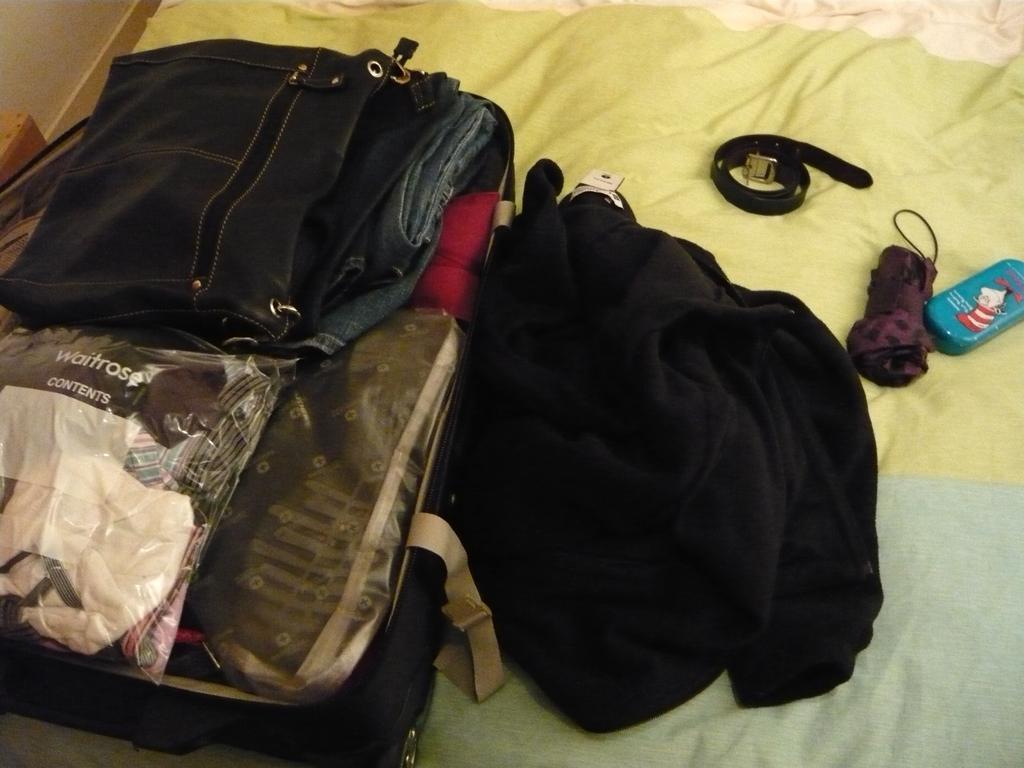Describe this image in one or two sentences. In this picture we have a bird which is covered with a cloth on the bed we can see every skate cloth and a box and an umbrella. 